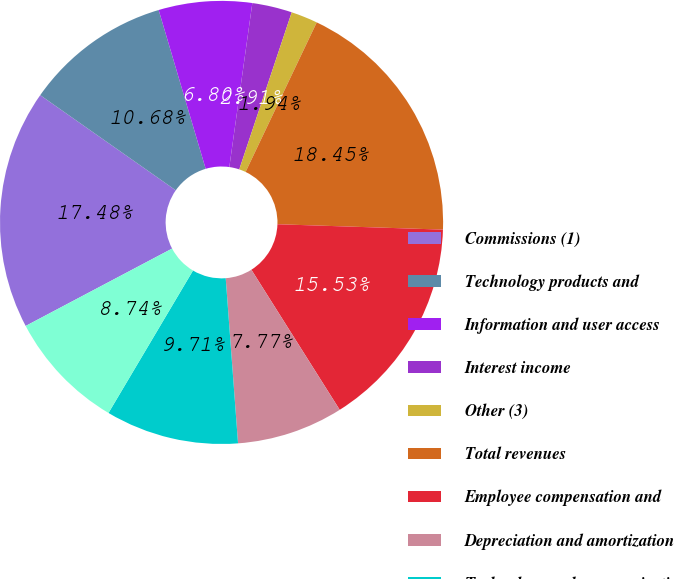<chart> <loc_0><loc_0><loc_500><loc_500><pie_chart><fcel>Commissions (1)<fcel>Technology products and<fcel>Information and user access<fcel>Interest income<fcel>Other (3)<fcel>Total revenues<fcel>Employee compensation and<fcel>Depreciation and amortization<fcel>Technology and communications<fcel>Professional and consulting<nl><fcel>17.48%<fcel>10.68%<fcel>6.8%<fcel>2.91%<fcel>1.94%<fcel>18.45%<fcel>15.53%<fcel>7.77%<fcel>9.71%<fcel>8.74%<nl></chart> 